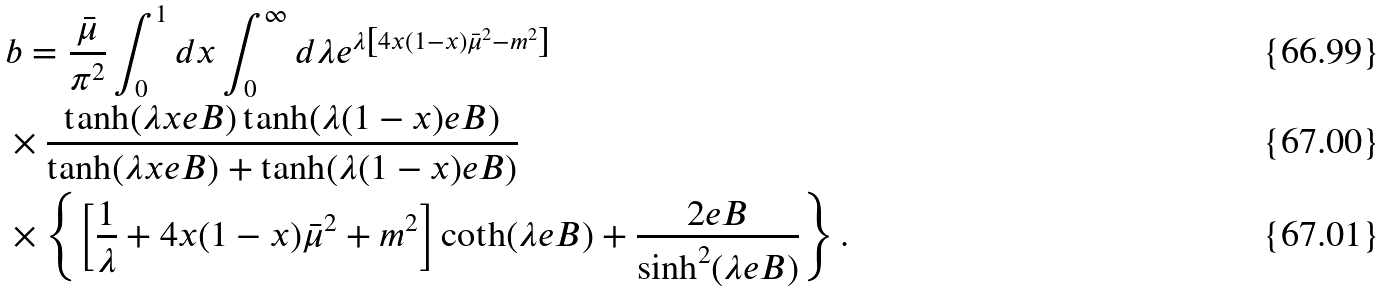Convert formula to latex. <formula><loc_0><loc_0><loc_500><loc_500>& b = \frac { { \bar { \mu } } } { \pi ^ { 2 } } \int _ { 0 } ^ { 1 } d x \int _ { 0 } ^ { \infty } d \lambda e ^ { \lambda \left [ 4 x ( 1 - x ) \bar { \mu } ^ { 2 } - m ^ { 2 } \right ] } \\ & \times \frac { \tanh ( \lambda x e B ) \tanh ( \lambda ( 1 - x ) e B ) } { \tanh ( \lambda x e B ) + \tanh ( \lambda ( 1 - x ) e B ) } \\ & \times \left \{ \left [ \frac { 1 } { \lambda } + 4 x ( 1 - x ) \bar { \mu } ^ { 2 } + m ^ { 2 } \right ] \coth ( \lambda e B ) + \frac { 2 e B } { \sinh ^ { 2 } ( \lambda e B ) } \right \} .</formula> 